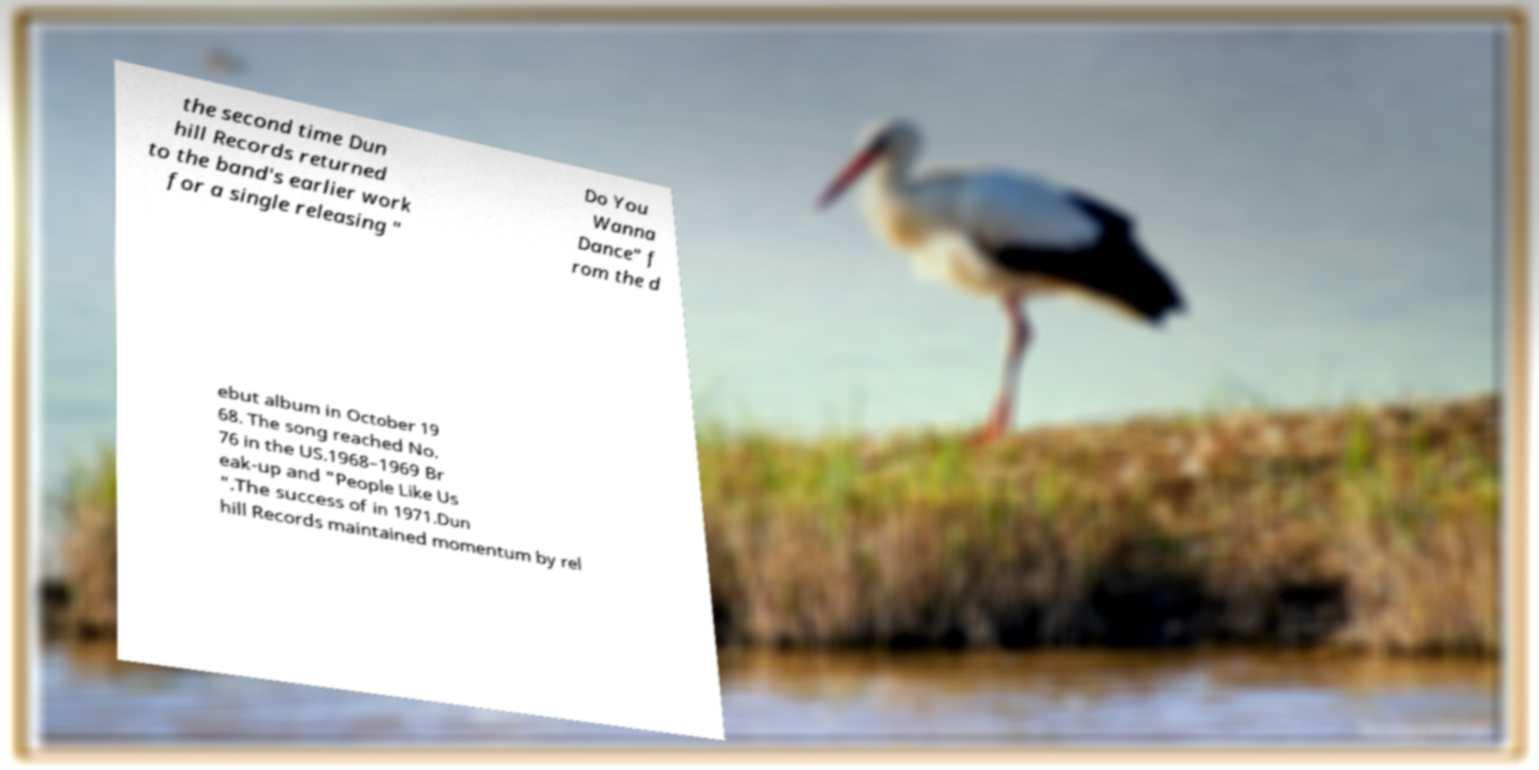Please identify and transcribe the text found in this image. the second time Dun hill Records returned to the band's earlier work for a single releasing " Do You Wanna Dance" f rom the d ebut album in October 19 68. The song reached No. 76 in the US.1968–1969 Br eak-up and "People Like Us ".The success of in 1971.Dun hill Records maintained momentum by rel 